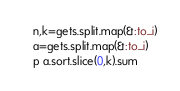Convert code to text. <code><loc_0><loc_0><loc_500><loc_500><_Ruby_>n,k=gets.split.map(&:to_i)
a=gets.split.map(&:to_i)
p a.sort.slice(0,k).sum</code> 